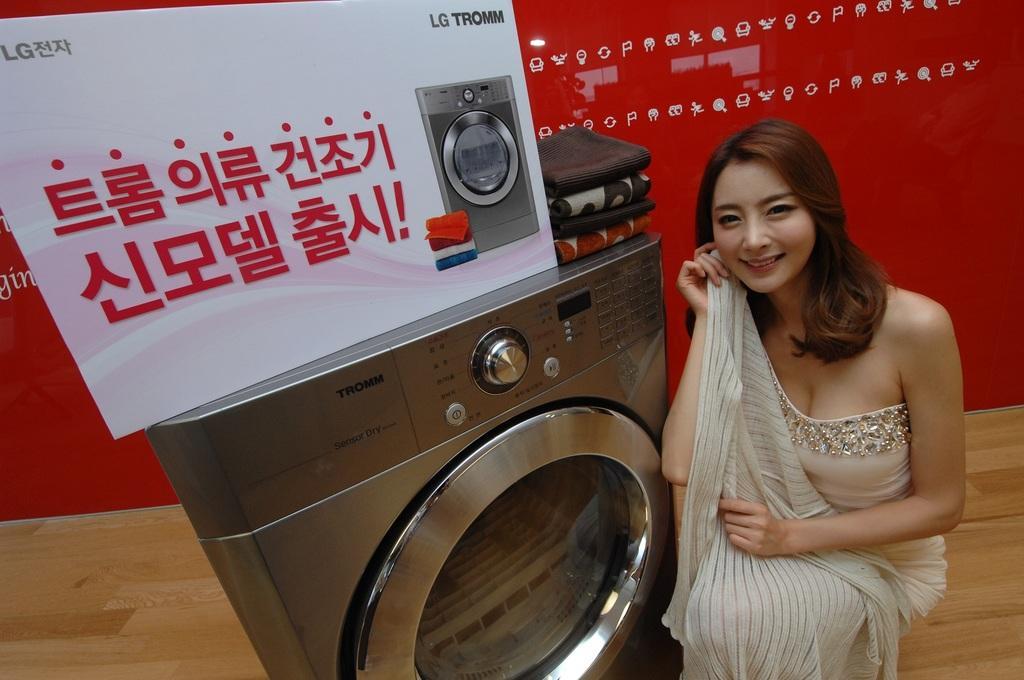In one or two sentences, can you explain what this image depicts? In this picture there is a girl who is sitting on the right side of the image and there is a washing machine in the center of the image, on which there is a poster and clothes, there is a poster in the background area of the image. 